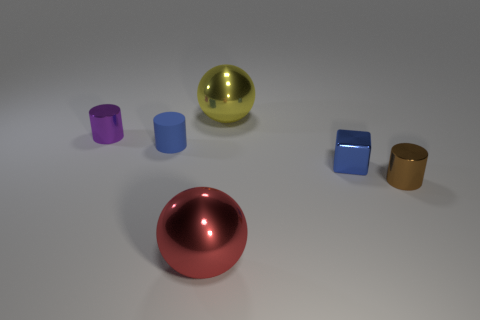The cylinder that is in front of the tiny purple cylinder and behind the tiny shiny cube is what color?
Provide a short and direct response. Blue. Are there any purple spheres?
Offer a terse response. No. Is the number of blue metallic things right of the brown metal object the same as the number of small purple metallic cylinders?
Make the answer very short. No. What number of other things are the same shape as the purple object?
Your response must be concise. 2. The blue metallic thing has what shape?
Provide a short and direct response. Cube. Do the small brown object and the blue cylinder have the same material?
Make the answer very short. No. Is the number of blue metal objects behind the blue matte cylinder the same as the number of small metallic cylinders that are in front of the large yellow metallic thing?
Your answer should be compact. No. Are there any matte objects right of the shiny cylinder on the right side of the blue thing that is in front of the tiny blue cylinder?
Your response must be concise. No. Does the blue matte cylinder have the same size as the blue cube?
Your response must be concise. Yes. What is the color of the tiny cylinder that is on the right side of the large metallic ball in front of the shiny cylinder that is behind the brown metal object?
Give a very brief answer. Brown. 